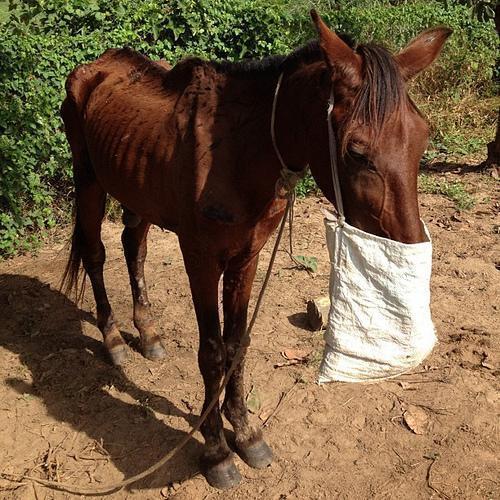How many legs does the horse have?
Give a very brief answer. 4. How many horses are in the picture?
Give a very brief answer. 1. How many ears does the horse have?
Give a very brief answer. 2. 